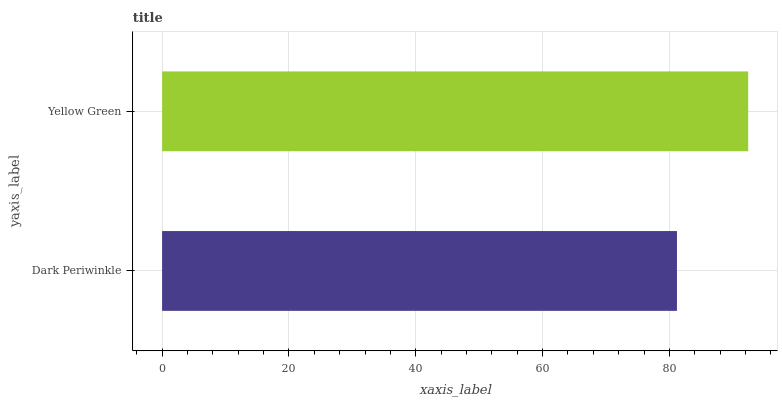Is Dark Periwinkle the minimum?
Answer yes or no. Yes. Is Yellow Green the maximum?
Answer yes or no. Yes. Is Yellow Green the minimum?
Answer yes or no. No. Is Yellow Green greater than Dark Periwinkle?
Answer yes or no. Yes. Is Dark Periwinkle less than Yellow Green?
Answer yes or no. Yes. Is Dark Periwinkle greater than Yellow Green?
Answer yes or no. No. Is Yellow Green less than Dark Periwinkle?
Answer yes or no. No. Is Yellow Green the high median?
Answer yes or no. Yes. Is Dark Periwinkle the low median?
Answer yes or no. Yes. Is Dark Periwinkle the high median?
Answer yes or no. No. Is Yellow Green the low median?
Answer yes or no. No. 